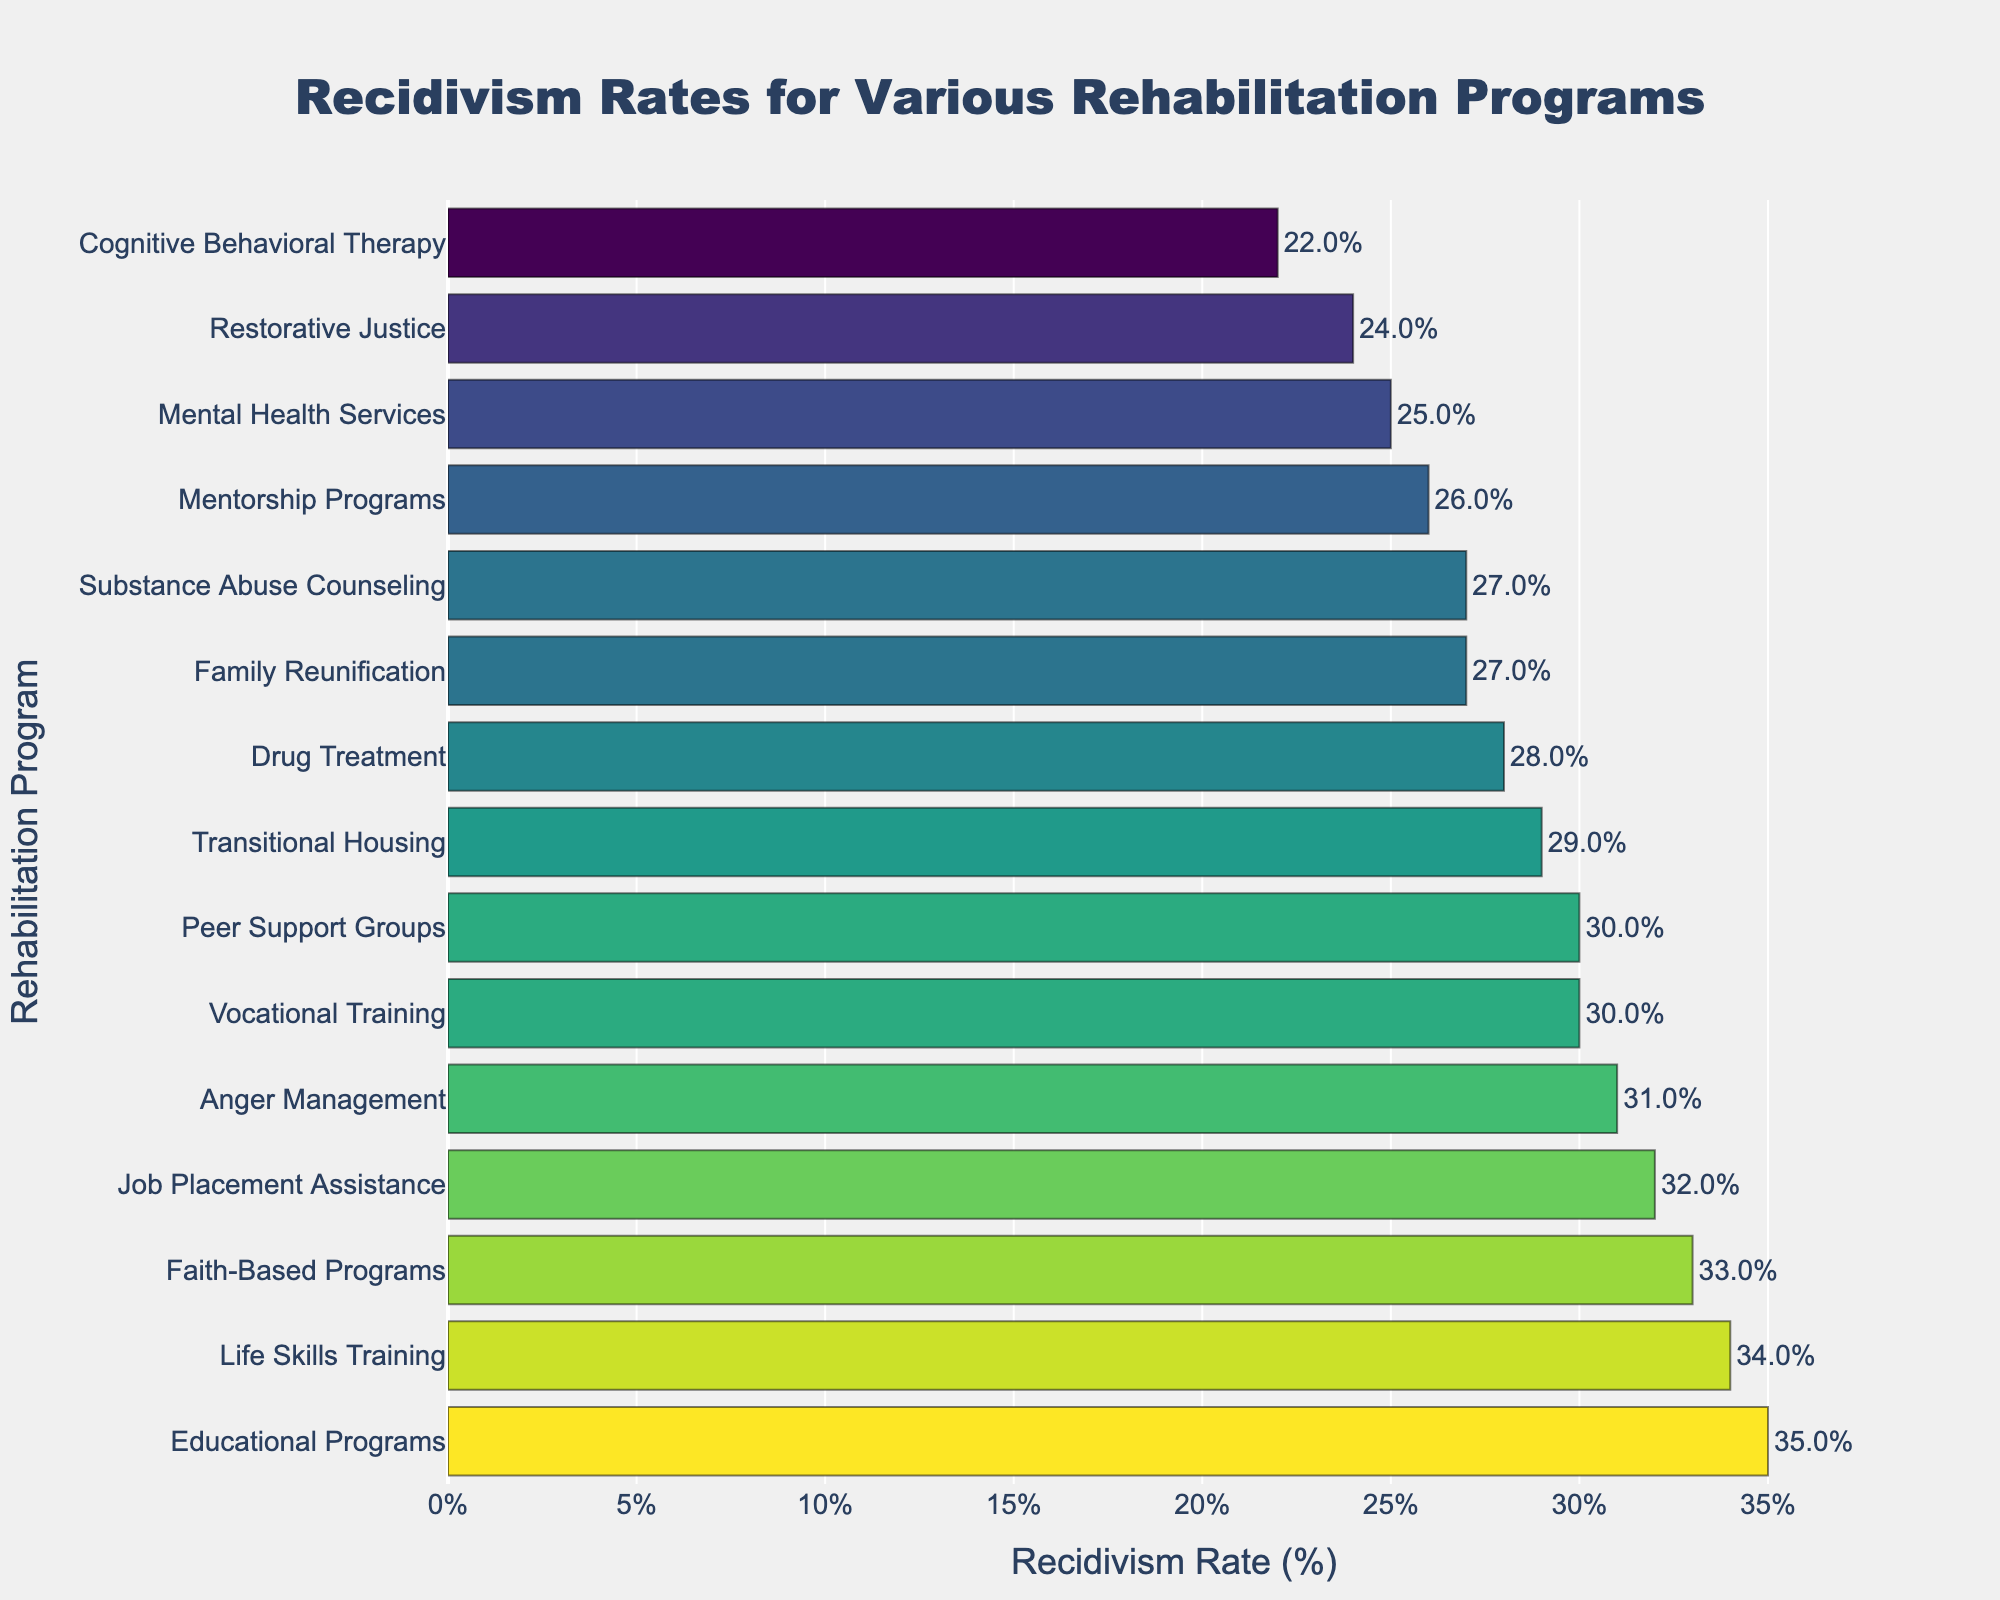Which rehabilitation program has the highest recidivism rate? The highest recidivism rate is the tallest bar in the chart. The highest bar represents Educational Programs with a recidivism rate of 35%.
Answer: Educational Programs Which rehabilitation program has the lowest recidivism rate? The lowest recidivism rate is the shortest bar in the chart. The shortest bar represents Cognitive Behavioral Therapy with a recidivism rate of 22%.
Answer: Cognitive Behavioral Therapy How much higher is the recidivism rate for Vocational Training compared to Restorative Justice? The recidivism rate for Vocational Training is 30%, and for Restorative Justice, it is 24%. The difference is 30% - 24% = 6%.
Answer: 6% What is the average recidivism rate of the top 3 programs with the highest rates? The top 3 programs with the highest rates are Educational Programs (35%), Life Skills Training (34%), and Faith-Based Programs (33%). The average is (35% + 34% + 33%) / 3 = 34%.
Answer: 34% Which program has a higher recidivism rate, Anger Management or Family Reunification? The chart shows Anger Management with a recidivism rate of 31% and Family Reunification with a rate of 27%. Anger Management has a higher rate.
Answer: Anger Management What is the total recidivism rate for Cognitive Behavioral Therapy, Drug Treatment, and Mental Health Services combined? The rates are Cognitive Behavioral Therapy (22%), Drug Treatment (28%), and Mental Health Services (25%). The total is 22% + 28% + 25% = 75%.
Answer: 75% Which programs have a recidivism rate between 27% and 30% inclusive, and how many are there? The programs with recidivism rates between 27% and 30% inclusive are Drug Treatment (28%), Family Reunification (27%), Mentorship Programs (26%), Transitional Housing (29%), Substance Abuse Counseling (27%), Peer Support Groups (30%). There are 6 such programs.
Answer: 6 If we categorize the programs into those above and below 30% recidivism rate, which category has more programs? Count the number of programs above 30% and below 30%. Above 30%: Educational Programs (35%), Life Skills Training (34%), Faith-Based Programs (33%), Anger Management (31%), Job Placement Assistance (32%). This category has 5 programs. Below 30%: The remaining programs, which are 10.
Answer: Below 30% 